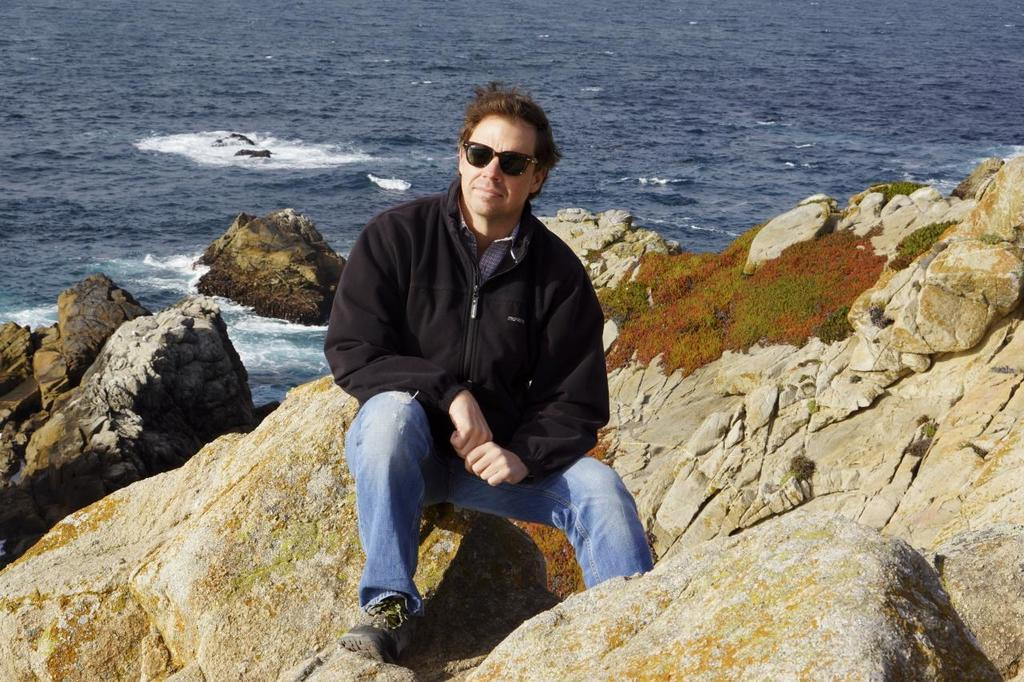Who is in the image? There is a man in the image. What is the man wearing? The man is wearing a jacket. What is the man doing in the image? The man is sitting on a rock and posing for a picture. What is the surrounding environment like in the image? There are many rocks around the man, and there is an ocean in the background of the image. What type of yam is being played in the background of the image? There is no yam or music present in the image; it features a man sitting on a rock and posing for a picture. 